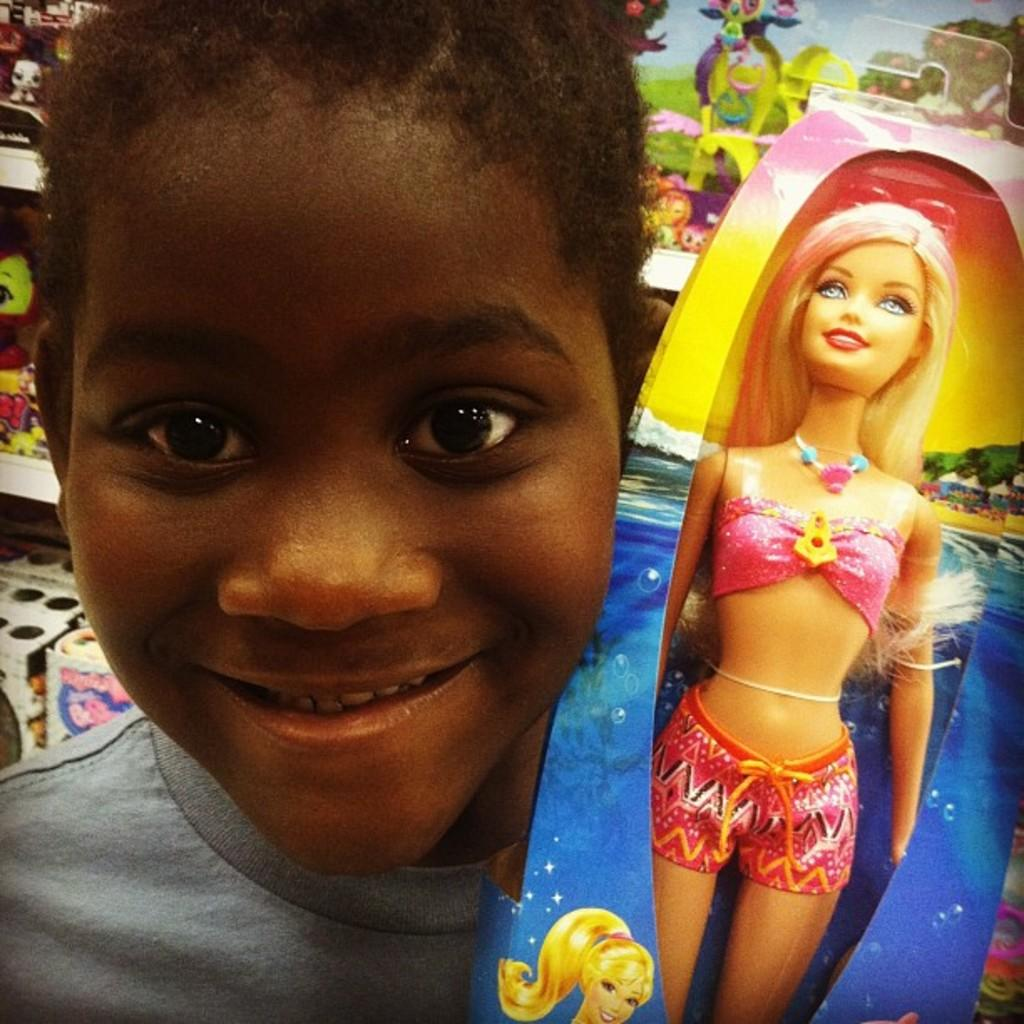What is the main subject of the image? The main subject of the image is a kid. What is the kid holding in the image? The kid is holding a Barbie doll. What can be seen in the background of the image? There are shelves with toys in the background of the image. Is there a volcano erupting in the background of the image? No, there is no volcano present in the image. What type of hair does the Barbie doll have? The provided facts do not mention the type of hair the Barbie doll has, so it cannot be determined from the image. 